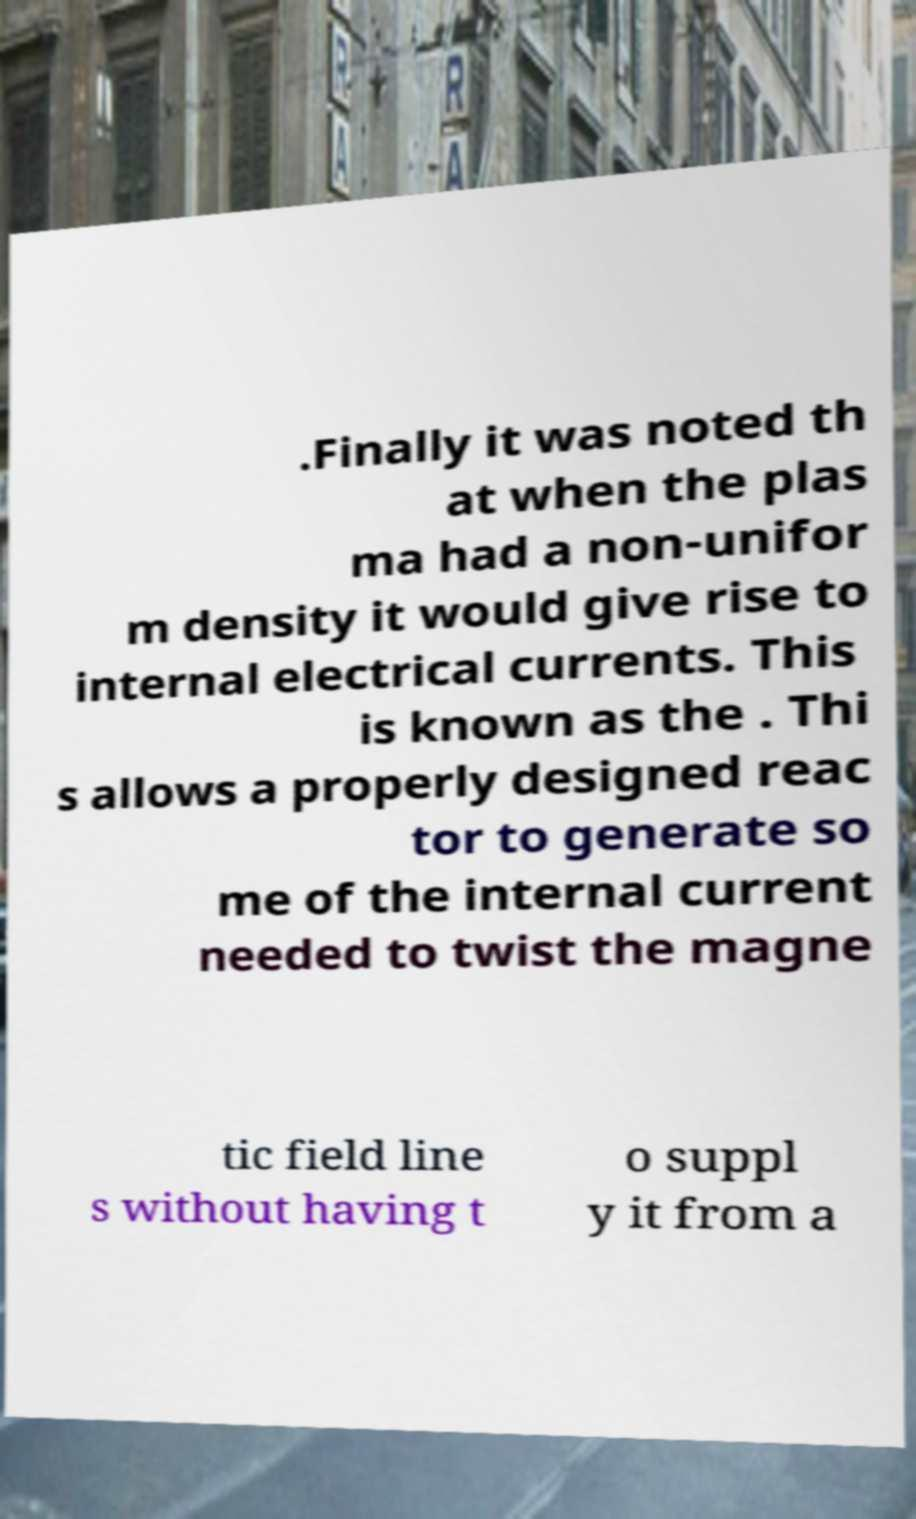For documentation purposes, I need the text within this image transcribed. Could you provide that? .Finally it was noted th at when the plas ma had a non-unifor m density it would give rise to internal electrical currents. This is known as the . Thi s allows a properly designed reac tor to generate so me of the internal current needed to twist the magne tic field line s without having t o suppl y it from a 